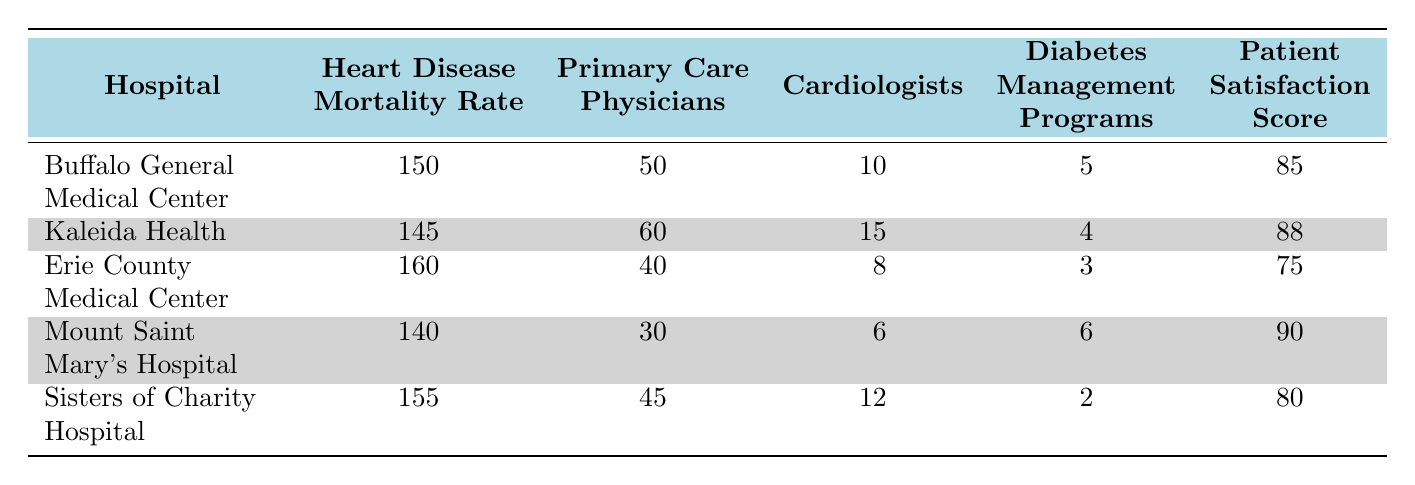What is the heart disease mortality rate for Kaleida Health? The table shows that Kaleida Health has a heart disease mortality rate of 145.
Answer: 145 Which hospital has the highest number of primary care physicians? By looking at the primary care physicians column, Kaleida Health has the highest number at 60.
Answer: Kaleida Health Is the patient satisfaction score for Erie County Medical Center above 80? The table indicates that Erie County Medical Center has a patient satisfaction score of 75, which is below 80.
Answer: No What is the difference in heart disease mortality rates between Mount Saint Mary's Hospital and Sisters of Charity Hospital? Mount Saint Mary's Hospital has a mortality rate of 140, while Sisters of Charity Hospital has a rate of 155. The difference is 155 - 140 = 15.
Answer: 15 What is the average number of cardiologists across all listed hospitals? To find the average, sum the number of cardiologists (10 + 15 + 8 + 6 + 12 = 51) and divide by the number of hospitals (5). The average is 51 / 5 = 10.2.
Answer: 10.2 Does Buffalo General Medical Center offer more diabetes management programs than Erie County Medical Center? Buffalo General Medical Center provides 5 diabetes management programs, while Erie County Medical Center has only 3. Therefore, Buffalo General Medical Center offers more.
Answer: Yes Which hospital has the lowest patient satisfaction score? Looking at the patient satisfaction score column, Erie County Medical Center has the lowest score of 75.
Answer: Erie County Medical Center What is the total number of diabetes management programs offered by all hospitals combined? Adding up the diabetes management programs gives us (5 + 4 + 3 + 6 + 2 = 20).
Answer: 20 Is the number of cardiologists at Sisters of Charity Hospital greater than that at Mount Saint Mary's Hospital? Sisters of Charity Hospital has 12 cardiologists, while Mount Saint Mary's Hospital has 6. Since 12 is greater than 6, the answer is yes.
Answer: Yes 